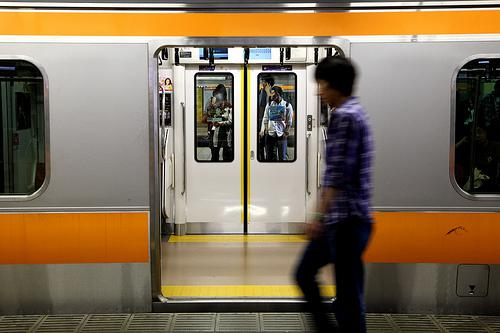Question: what color is the subway?
Choices:
A. Grey, orange.
B. Black, white.
C. White, yellow.
D. Pink, black.
Answer with the letter. Answer: A Question: where is this shot?
Choices:
A. Airport.
B. Suburban home.
C. Subway station.
D. Big city bank.
Answer with the letter. Answer: C Question: what are the people standing on?
Choices:
A. Stage.
B. Stairs.
C. Balcony.
D. Platform.
Answer with the letter. Answer: D Question: what color are the windows?
Choices:
A. White.
B. Red.
C. Green.
D. Black.
Answer with the letter. Answer: D Question: how many animals are there?
Choices:
A. 1.
B. 2.
C. 3.
D. 0.
Answer with the letter. Answer: D Question: how many doors are shown?
Choices:
A. 3.
B. 4.
C. 5.
D. 2.
Answer with the letter. Answer: D 